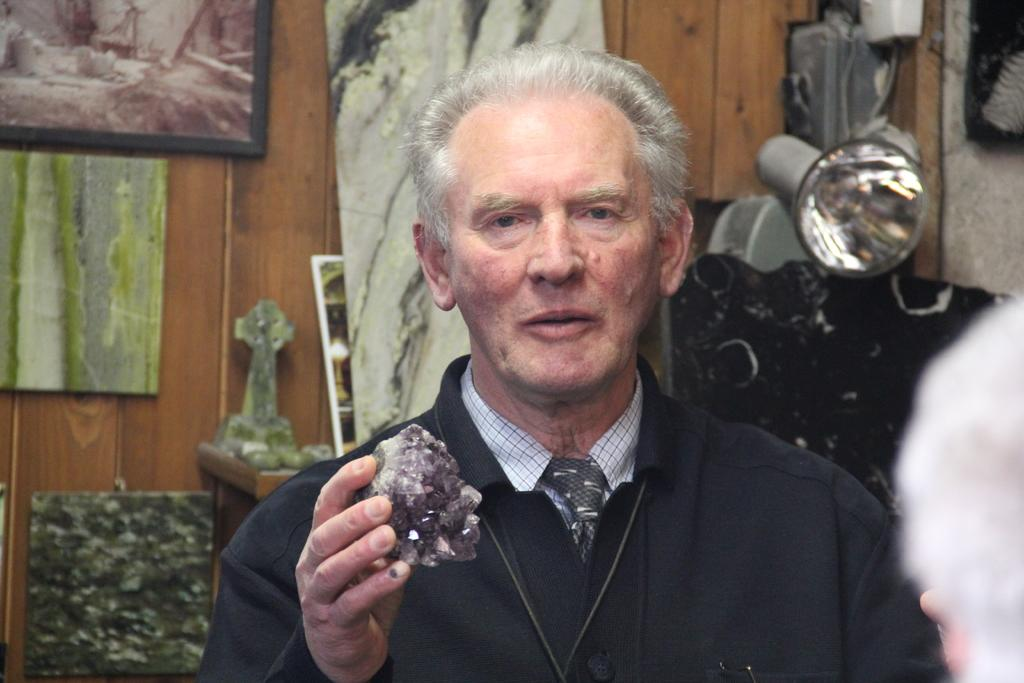Where was the image taken? The image was taken in a room. What is the main subject in the foreground of the picture? There is a man in the foreground of the picture. What is the man holding in the image? The man is holding a stone. What can be seen in the background of the picture? There are frames, stones, and a light in the background of the picture. What type of writing can be seen on the stones in the image? There is no writing visible on the stones in the image. Is there any indication of a power source in the image? There is no indication of a power source in the image. 